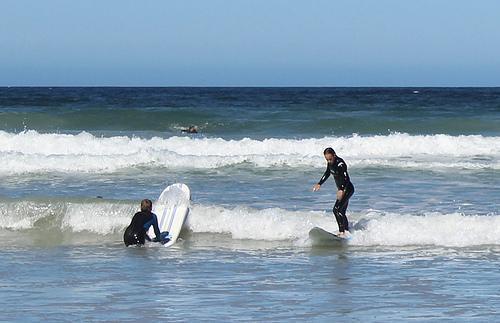How many people are there?
Give a very brief answer. 3. 